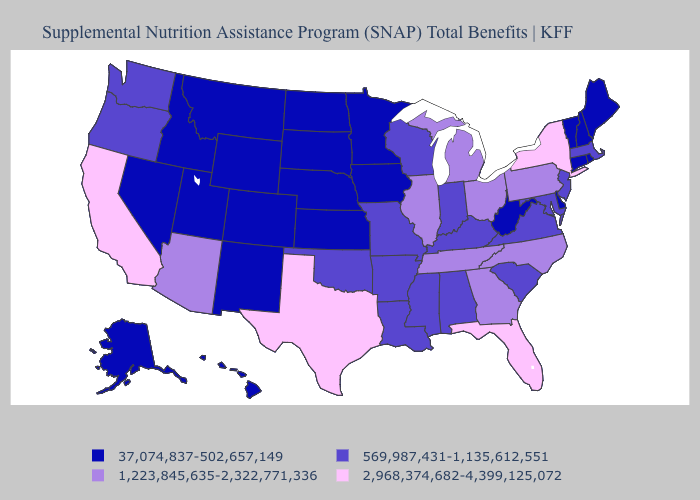What is the value of Louisiana?
Answer briefly. 569,987,431-1,135,612,551. Which states have the lowest value in the West?
Keep it brief. Alaska, Colorado, Hawaii, Idaho, Montana, Nevada, New Mexico, Utah, Wyoming. Name the states that have a value in the range 569,987,431-1,135,612,551?
Answer briefly. Alabama, Arkansas, Indiana, Kentucky, Louisiana, Maryland, Massachusetts, Mississippi, Missouri, New Jersey, Oklahoma, Oregon, South Carolina, Virginia, Washington, Wisconsin. Name the states that have a value in the range 569,987,431-1,135,612,551?
Quick response, please. Alabama, Arkansas, Indiana, Kentucky, Louisiana, Maryland, Massachusetts, Mississippi, Missouri, New Jersey, Oklahoma, Oregon, South Carolina, Virginia, Washington, Wisconsin. Which states hav the highest value in the South?
Short answer required. Florida, Texas. Name the states that have a value in the range 569,987,431-1,135,612,551?
Short answer required. Alabama, Arkansas, Indiana, Kentucky, Louisiana, Maryland, Massachusetts, Mississippi, Missouri, New Jersey, Oklahoma, Oregon, South Carolina, Virginia, Washington, Wisconsin. Which states have the highest value in the USA?
Be succinct. California, Florida, New York, Texas. Does Michigan have the highest value in the MidWest?
Give a very brief answer. Yes. Name the states that have a value in the range 569,987,431-1,135,612,551?
Answer briefly. Alabama, Arkansas, Indiana, Kentucky, Louisiana, Maryland, Massachusetts, Mississippi, Missouri, New Jersey, Oklahoma, Oregon, South Carolina, Virginia, Washington, Wisconsin. Does Colorado have a lower value than Montana?
Give a very brief answer. No. Which states have the lowest value in the USA?
Keep it brief. Alaska, Colorado, Connecticut, Delaware, Hawaii, Idaho, Iowa, Kansas, Maine, Minnesota, Montana, Nebraska, Nevada, New Hampshire, New Mexico, North Dakota, Rhode Island, South Dakota, Utah, Vermont, West Virginia, Wyoming. Does Arizona have a higher value than Florida?
Answer briefly. No. What is the lowest value in the South?
Give a very brief answer. 37,074,837-502,657,149. Name the states that have a value in the range 1,223,845,635-2,322,771,336?
Answer briefly. Arizona, Georgia, Illinois, Michigan, North Carolina, Ohio, Pennsylvania, Tennessee. What is the lowest value in the USA?
Be succinct. 37,074,837-502,657,149. 